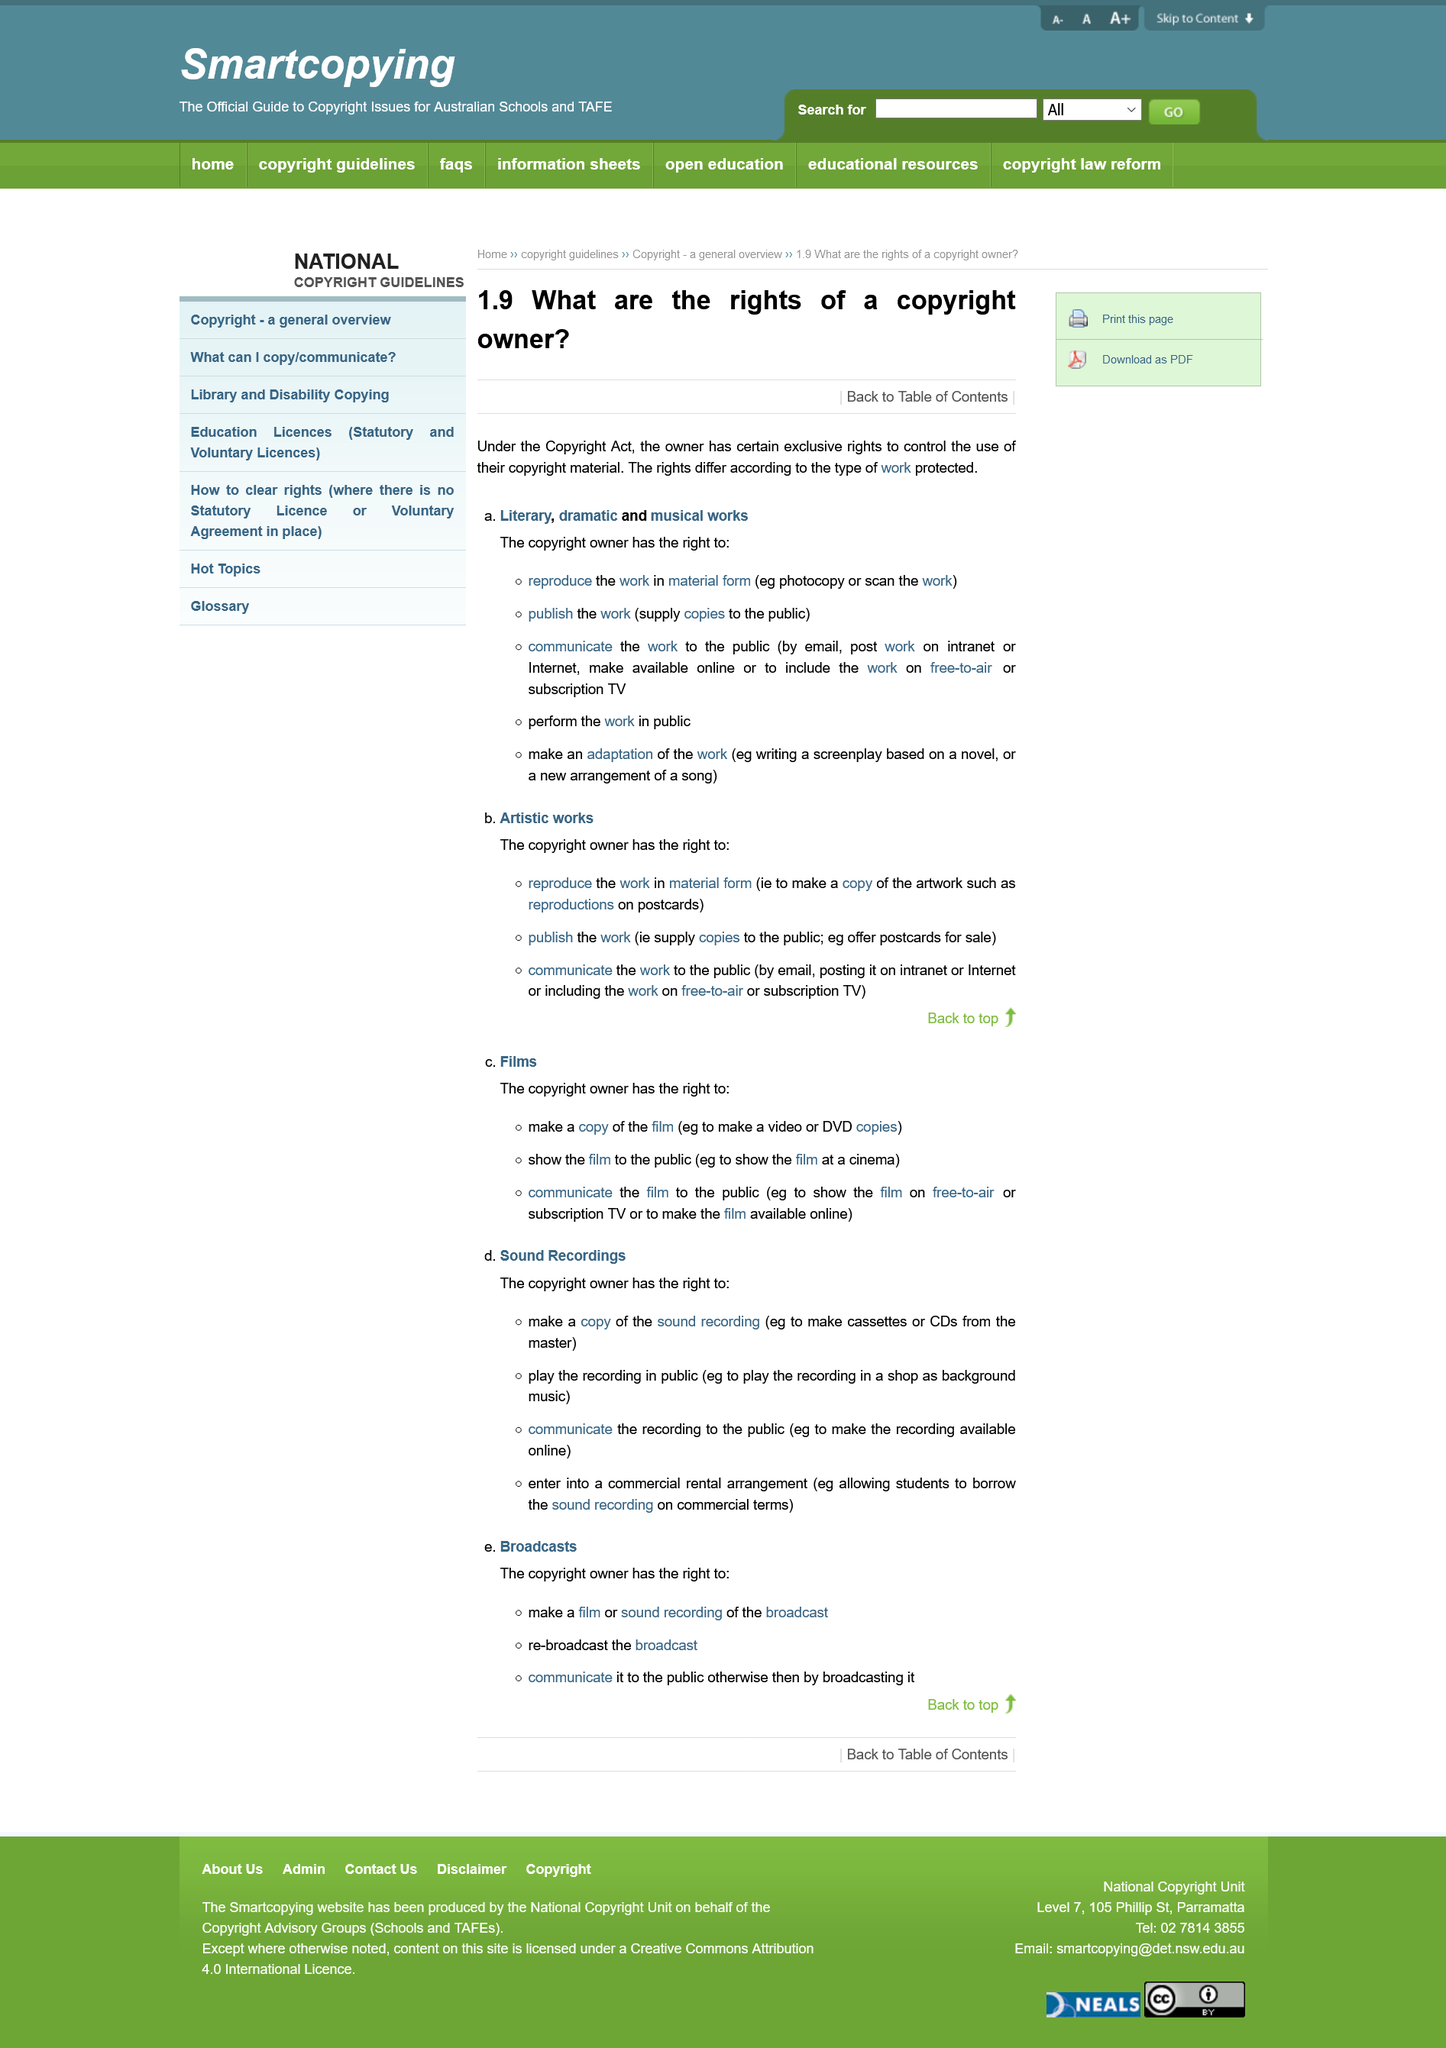Highlight a few significant elements in this photo. Yes, under the Copyright Act, the copyright owner has the right to perform the work in public. Under the Copyright Act, it is permissible for the copyright owner to create an adaptation of their original work. The copyright owner has the right to publish the work, as stated under the Copyright Act. 